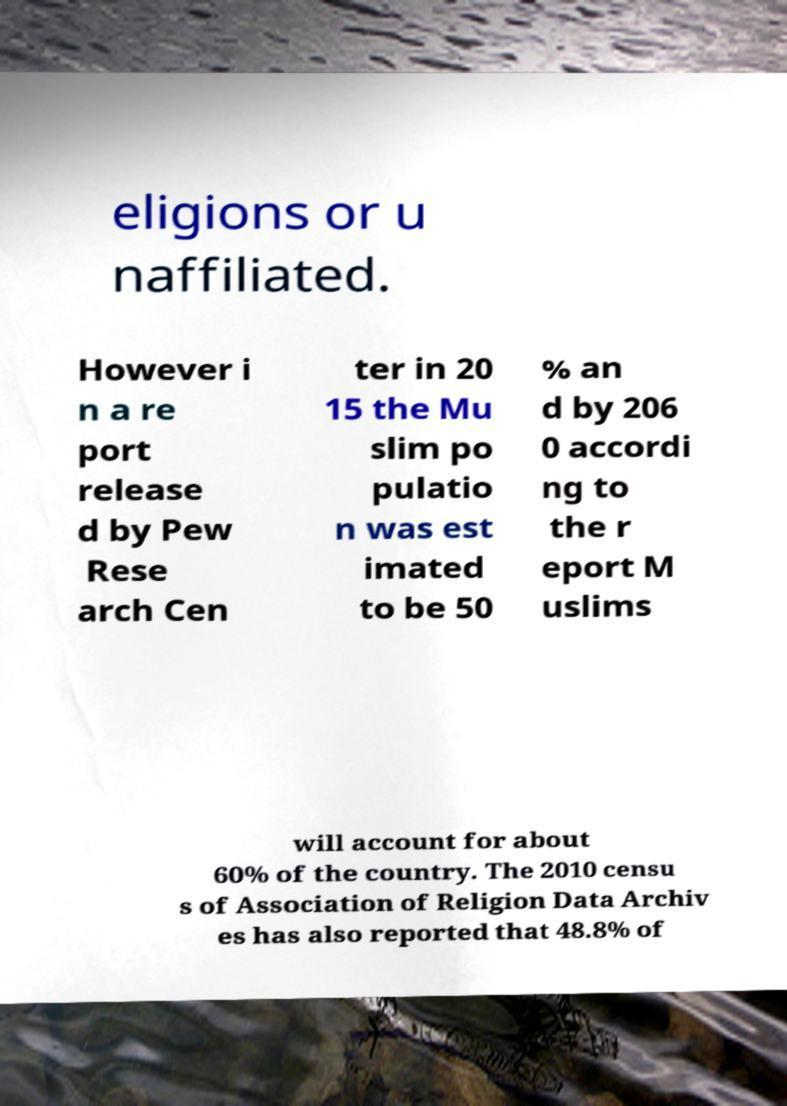Could you extract and type out the text from this image? eligions or u naffiliated. However i n a re port release d by Pew Rese arch Cen ter in 20 15 the Mu slim po pulatio n was est imated to be 50 % an d by 206 0 accordi ng to the r eport M uslims will account for about 60% of the country. The 2010 censu s of Association of Religion Data Archiv es has also reported that 48.8% of 